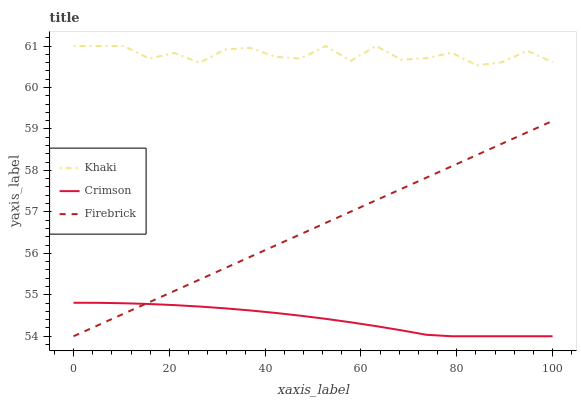Does Crimson have the minimum area under the curve?
Answer yes or no. Yes. Does Khaki have the maximum area under the curve?
Answer yes or no. Yes. Does Firebrick have the minimum area under the curve?
Answer yes or no. No. Does Firebrick have the maximum area under the curve?
Answer yes or no. No. Is Firebrick the smoothest?
Answer yes or no. Yes. Is Khaki the roughest?
Answer yes or no. Yes. Is Khaki the smoothest?
Answer yes or no. No. Is Firebrick the roughest?
Answer yes or no. No. Does Crimson have the lowest value?
Answer yes or no. Yes. Does Khaki have the lowest value?
Answer yes or no. No. Does Khaki have the highest value?
Answer yes or no. Yes. Does Firebrick have the highest value?
Answer yes or no. No. Is Firebrick less than Khaki?
Answer yes or no. Yes. Is Khaki greater than Crimson?
Answer yes or no. Yes. Does Firebrick intersect Crimson?
Answer yes or no. Yes. Is Firebrick less than Crimson?
Answer yes or no. No. Is Firebrick greater than Crimson?
Answer yes or no. No. Does Firebrick intersect Khaki?
Answer yes or no. No. 